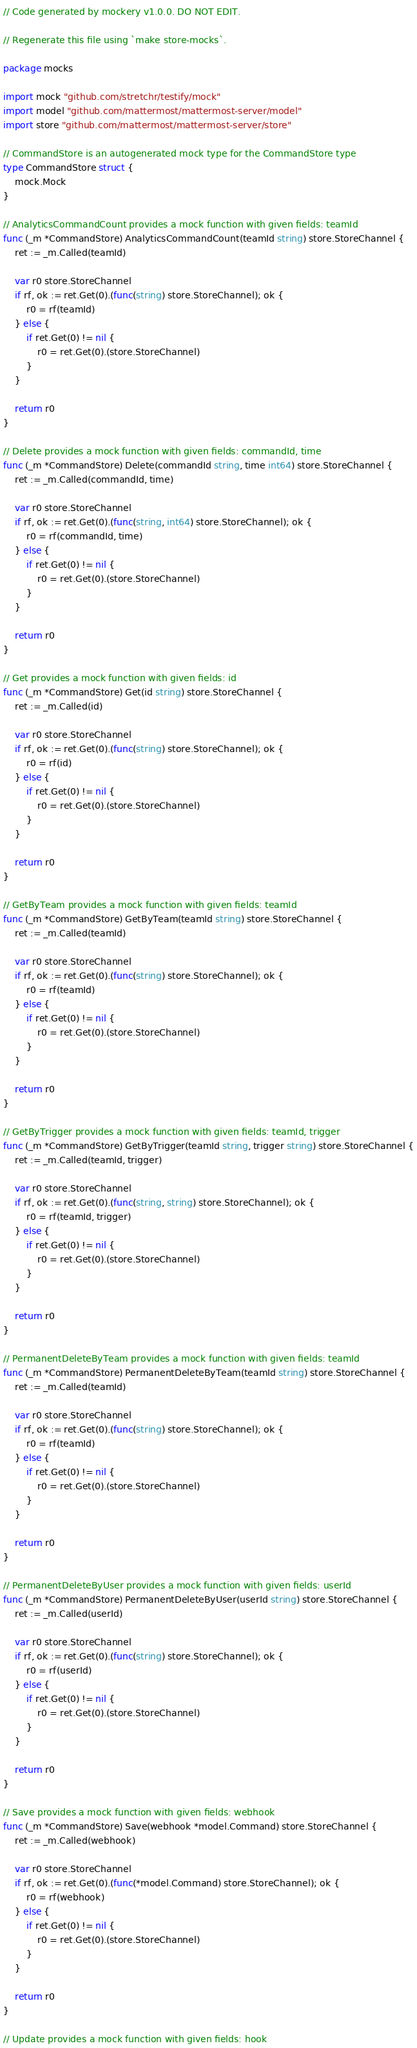Convert code to text. <code><loc_0><loc_0><loc_500><loc_500><_Go_>// Code generated by mockery v1.0.0. DO NOT EDIT.

// Regenerate this file using `make store-mocks`.

package mocks

import mock "github.com/stretchr/testify/mock"
import model "github.com/mattermost/mattermost-server/model"
import store "github.com/mattermost/mattermost-server/store"

// CommandStore is an autogenerated mock type for the CommandStore type
type CommandStore struct {
	mock.Mock
}

// AnalyticsCommandCount provides a mock function with given fields: teamId
func (_m *CommandStore) AnalyticsCommandCount(teamId string) store.StoreChannel {
	ret := _m.Called(teamId)

	var r0 store.StoreChannel
	if rf, ok := ret.Get(0).(func(string) store.StoreChannel); ok {
		r0 = rf(teamId)
	} else {
		if ret.Get(0) != nil {
			r0 = ret.Get(0).(store.StoreChannel)
		}
	}

	return r0
}

// Delete provides a mock function with given fields: commandId, time
func (_m *CommandStore) Delete(commandId string, time int64) store.StoreChannel {
	ret := _m.Called(commandId, time)

	var r0 store.StoreChannel
	if rf, ok := ret.Get(0).(func(string, int64) store.StoreChannel); ok {
		r0 = rf(commandId, time)
	} else {
		if ret.Get(0) != nil {
			r0 = ret.Get(0).(store.StoreChannel)
		}
	}

	return r0
}

// Get provides a mock function with given fields: id
func (_m *CommandStore) Get(id string) store.StoreChannel {
	ret := _m.Called(id)

	var r0 store.StoreChannel
	if rf, ok := ret.Get(0).(func(string) store.StoreChannel); ok {
		r0 = rf(id)
	} else {
		if ret.Get(0) != nil {
			r0 = ret.Get(0).(store.StoreChannel)
		}
	}

	return r0
}

// GetByTeam provides a mock function with given fields: teamId
func (_m *CommandStore) GetByTeam(teamId string) store.StoreChannel {
	ret := _m.Called(teamId)

	var r0 store.StoreChannel
	if rf, ok := ret.Get(0).(func(string) store.StoreChannel); ok {
		r0 = rf(teamId)
	} else {
		if ret.Get(0) != nil {
			r0 = ret.Get(0).(store.StoreChannel)
		}
	}

	return r0
}

// GetByTrigger provides a mock function with given fields: teamId, trigger
func (_m *CommandStore) GetByTrigger(teamId string, trigger string) store.StoreChannel {
	ret := _m.Called(teamId, trigger)

	var r0 store.StoreChannel
	if rf, ok := ret.Get(0).(func(string, string) store.StoreChannel); ok {
		r0 = rf(teamId, trigger)
	} else {
		if ret.Get(0) != nil {
			r0 = ret.Get(0).(store.StoreChannel)
		}
	}

	return r0
}

// PermanentDeleteByTeam provides a mock function with given fields: teamId
func (_m *CommandStore) PermanentDeleteByTeam(teamId string) store.StoreChannel {
	ret := _m.Called(teamId)

	var r0 store.StoreChannel
	if rf, ok := ret.Get(0).(func(string) store.StoreChannel); ok {
		r0 = rf(teamId)
	} else {
		if ret.Get(0) != nil {
			r0 = ret.Get(0).(store.StoreChannel)
		}
	}

	return r0
}

// PermanentDeleteByUser provides a mock function with given fields: userId
func (_m *CommandStore) PermanentDeleteByUser(userId string) store.StoreChannel {
	ret := _m.Called(userId)

	var r0 store.StoreChannel
	if rf, ok := ret.Get(0).(func(string) store.StoreChannel); ok {
		r0 = rf(userId)
	} else {
		if ret.Get(0) != nil {
			r0 = ret.Get(0).(store.StoreChannel)
		}
	}

	return r0
}

// Save provides a mock function with given fields: webhook
func (_m *CommandStore) Save(webhook *model.Command) store.StoreChannel {
	ret := _m.Called(webhook)

	var r0 store.StoreChannel
	if rf, ok := ret.Get(0).(func(*model.Command) store.StoreChannel); ok {
		r0 = rf(webhook)
	} else {
		if ret.Get(0) != nil {
			r0 = ret.Get(0).(store.StoreChannel)
		}
	}

	return r0
}

// Update provides a mock function with given fields: hook</code> 